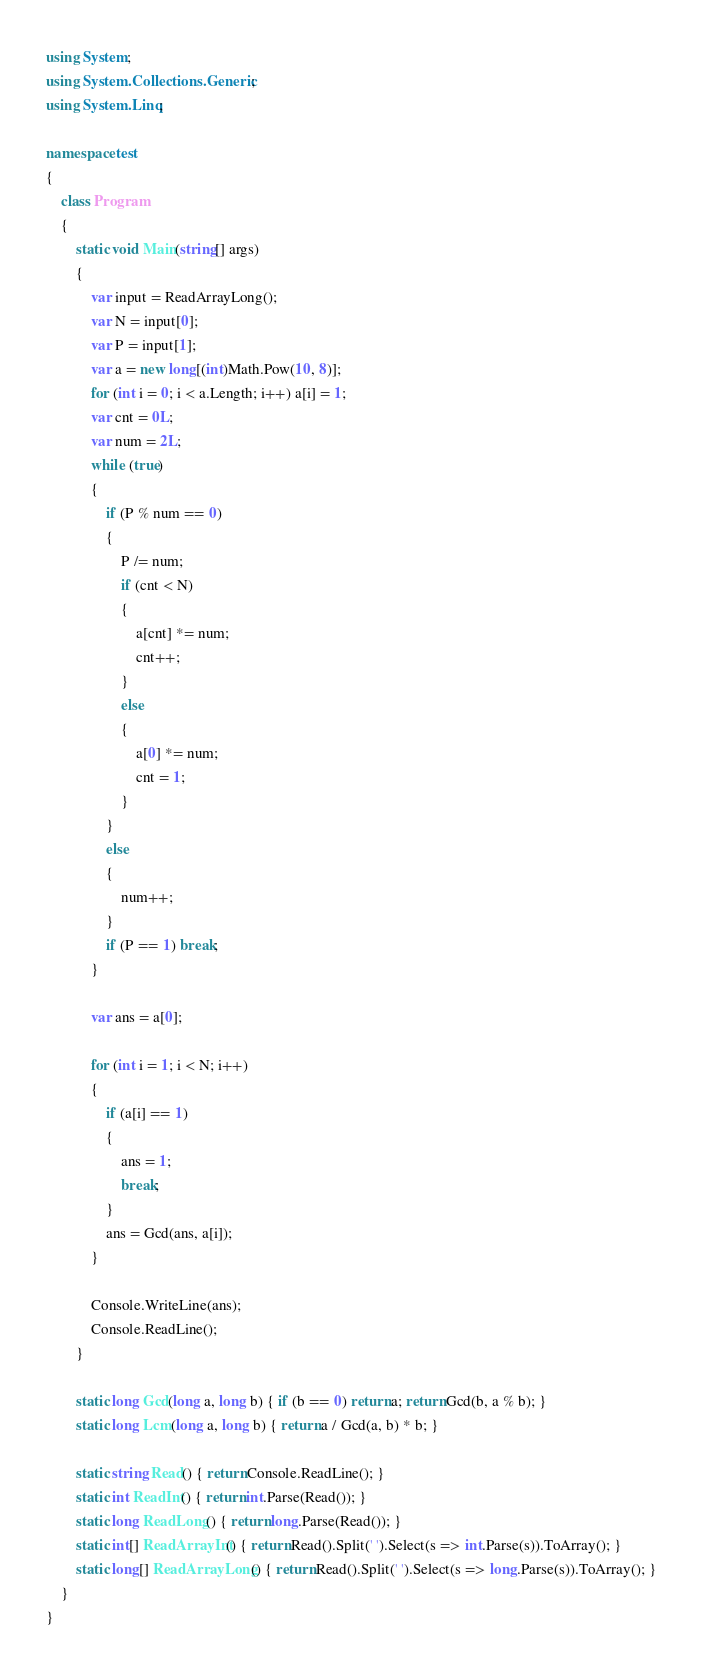<code> <loc_0><loc_0><loc_500><loc_500><_C#_>using System;
using System.Collections.Generic;
using System.Linq;

namespace test
{
    class Program
    {
        static void Main(string[] args)
        {
            var input = ReadArrayLong();
            var N = input[0];
            var P = input[1];
            var a = new long[(int)Math.Pow(10, 8)];
            for (int i = 0; i < a.Length; i++) a[i] = 1;
            var cnt = 0L;
            var num = 2L;
            while (true)
            {
                if (P % num == 0)
                {
                    P /= num;
                    if (cnt < N)
                    {
                        a[cnt] *= num;
                        cnt++;
                    }
                    else
                    {
                        a[0] *= num;
                        cnt = 1;
                    }
                }
                else
                {
                    num++;
                }
                if (P == 1) break;
            }

            var ans = a[0];

            for (int i = 1; i < N; i++)
            {
                if (a[i] == 1)
                {
                    ans = 1;
                    break;
                }
                ans = Gcd(ans, a[i]);
            }

            Console.WriteLine(ans);
            Console.ReadLine();
        }

        static long Gcd(long a, long b) { if (b == 0) return a; return Gcd(b, a % b); }
        static long Lcm(long a, long b) { return a / Gcd(a, b) * b; }

        static string Read() { return Console.ReadLine(); }
        static int ReadInt() { return int.Parse(Read()); }
        static long ReadLong() { return long.Parse(Read()); }
        static int[] ReadArrayInt() { return Read().Split(' ').Select(s => int.Parse(s)).ToArray(); }
        static long[] ReadArrayLong() { return Read().Split(' ').Select(s => long.Parse(s)).ToArray(); }
    }
}</code> 